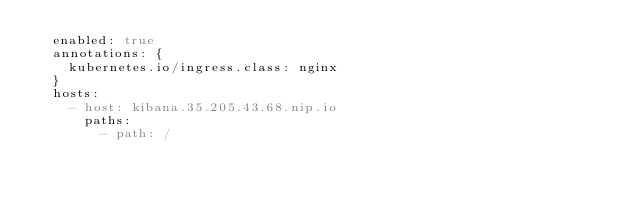Convert code to text. <code><loc_0><loc_0><loc_500><loc_500><_YAML_>  enabled: true
  annotations: {
    kubernetes.io/ingress.class: nginx
  }
  hosts:
    - host: kibana.35.205.43.68.nip.io
      paths:
        - path: /
</code> 